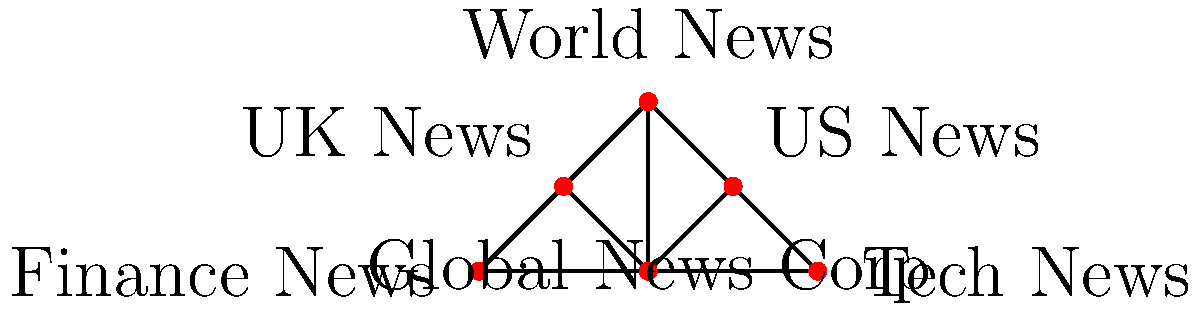Based on the network diagram of global media ownership, which subsidiary appears to have the most diverse connections, potentially indicating a strategic position in the network? How might this positioning affect the flow of information across different regions? To answer this question, we need to analyze the connections in the network diagram:

1. Identify all entities in the network:
   - Global News Corp (center)
   - US News
   - UK News
   - World News
   - Tech News
   - Finance News

2. Examine the connections of each entity:
   - Global News Corp: Connected to all other entities (5 connections)
   - US News: Connected to Global News Corp, World News, and Tech News (3 connections)
   - UK News: Connected to Global News Corp, World News, and Finance News (3 connections)
   - World News: Connected to Global News Corp, US News, and UK News (3 connections)
   - Tech News: Connected to Global News Corp and US News (2 connections)
   - Finance News: Connected to Global News Corp and UK News (2 connections)

3. Identify the entity with the most diverse connections:
   World News has connections to entities in different regions (US and UK) as well as the central Global News Corp.

4. Analyze the strategic position:
   World News' position allows it to receive information from both US and UK sources, as well as the central Global News Corp. This positioning potentially enables it to aggregate and disseminate news from multiple perspectives.

5. Consider the impact on information flow:
   - World News can act as a bridge between US and UK news sources.
   - It can potentially influence the narrative by selecting which information to emphasize from different regional sources.
   - Its connection to Global News Corp allows it to both receive and contribute to global narratives.
Answer: World News; strategic position enables diverse information flow between regions and global narratives. 